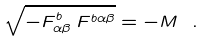Convert formula to latex. <formula><loc_0><loc_0><loc_500><loc_500>\sqrt { - F _ { \alpha \beta } ^ { b } \, F ^ { b \alpha \beta } } = - M \ .</formula> 